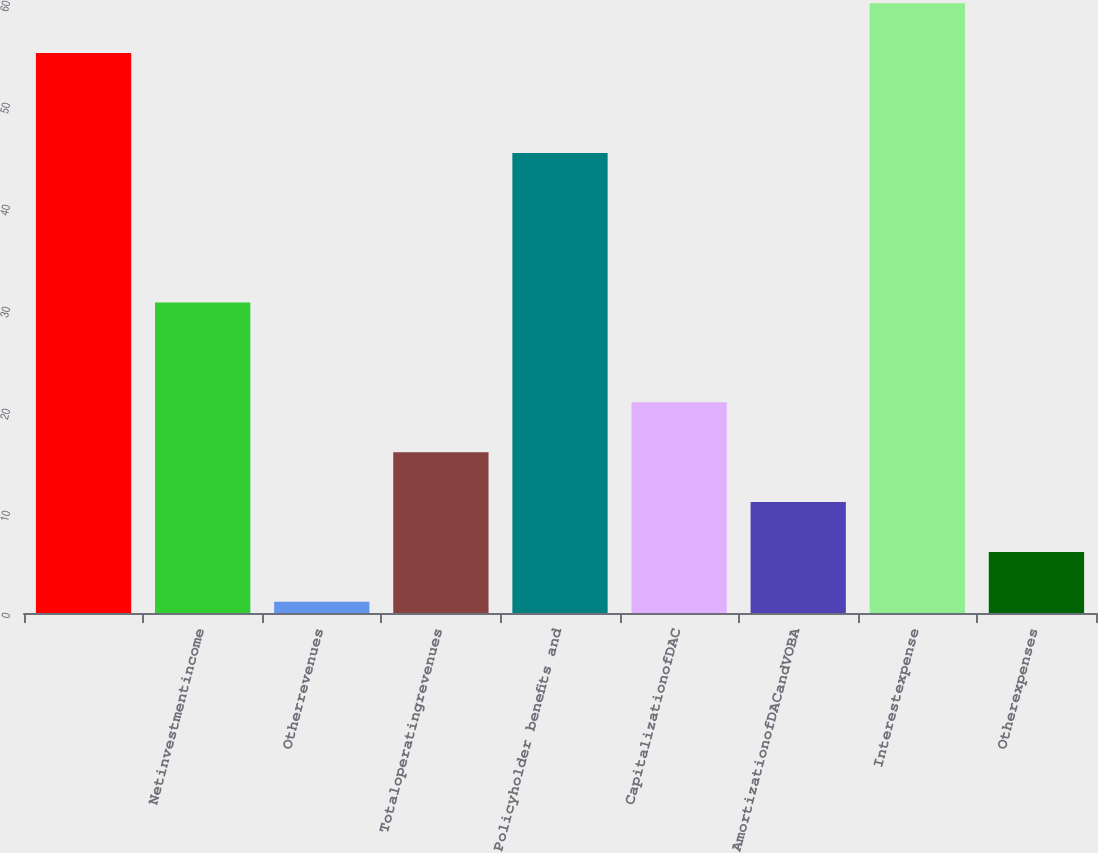Convert chart. <chart><loc_0><loc_0><loc_500><loc_500><bar_chart><ecel><fcel>Netinvestmentincome<fcel>Otherrevenues<fcel>Totaloperatingrevenues<fcel>Policyholder benefits and<fcel>CapitalizationofDAC<fcel>AmortizationofDACandVOBA<fcel>Interestexpense<fcel>Otherexpenses<nl><fcel>54.89<fcel>30.44<fcel>1.1<fcel>15.77<fcel>45.11<fcel>20.66<fcel>10.88<fcel>59.78<fcel>5.99<nl></chart> 